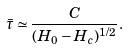<formula> <loc_0><loc_0><loc_500><loc_500>\bar { \tau } \simeq \frac { C } { ( H _ { 0 } - H _ { c } ) ^ { 1 / 2 } } .</formula> 